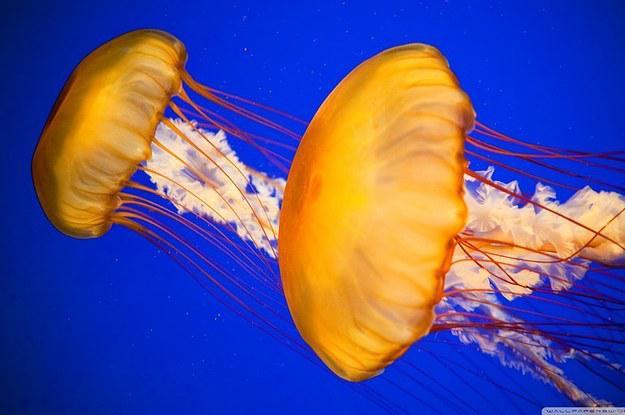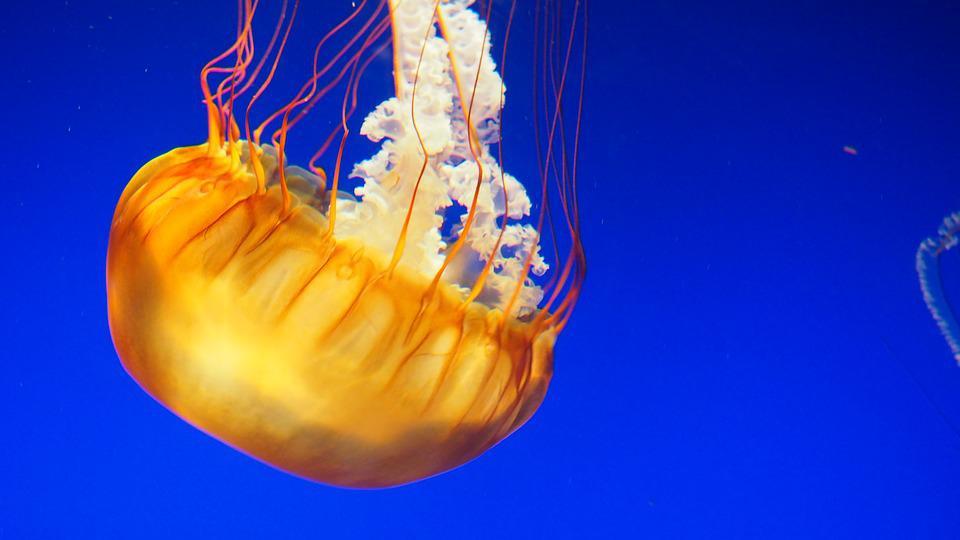The first image is the image on the left, the second image is the image on the right. Assess this claim about the two images: "There are a total of three jellyfish.". Correct or not? Answer yes or no. Yes. 